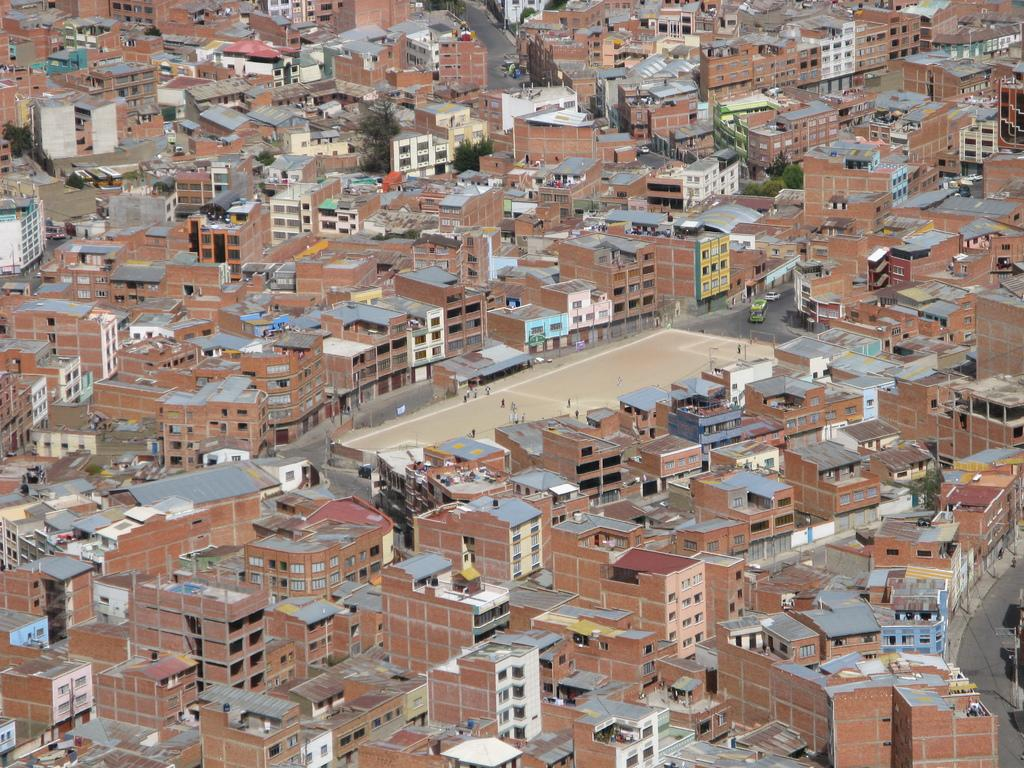What type of structures can be seen in the image? There are buildings in the image. What type of natural elements can be seen in the image? There are trees in the image. What activity are people engaged in within the image? There are people playing in the ground in the image. What type of star can be seen in the image? There is no star visible in the image; it only contains buildings, trees, and people playing in the ground. 